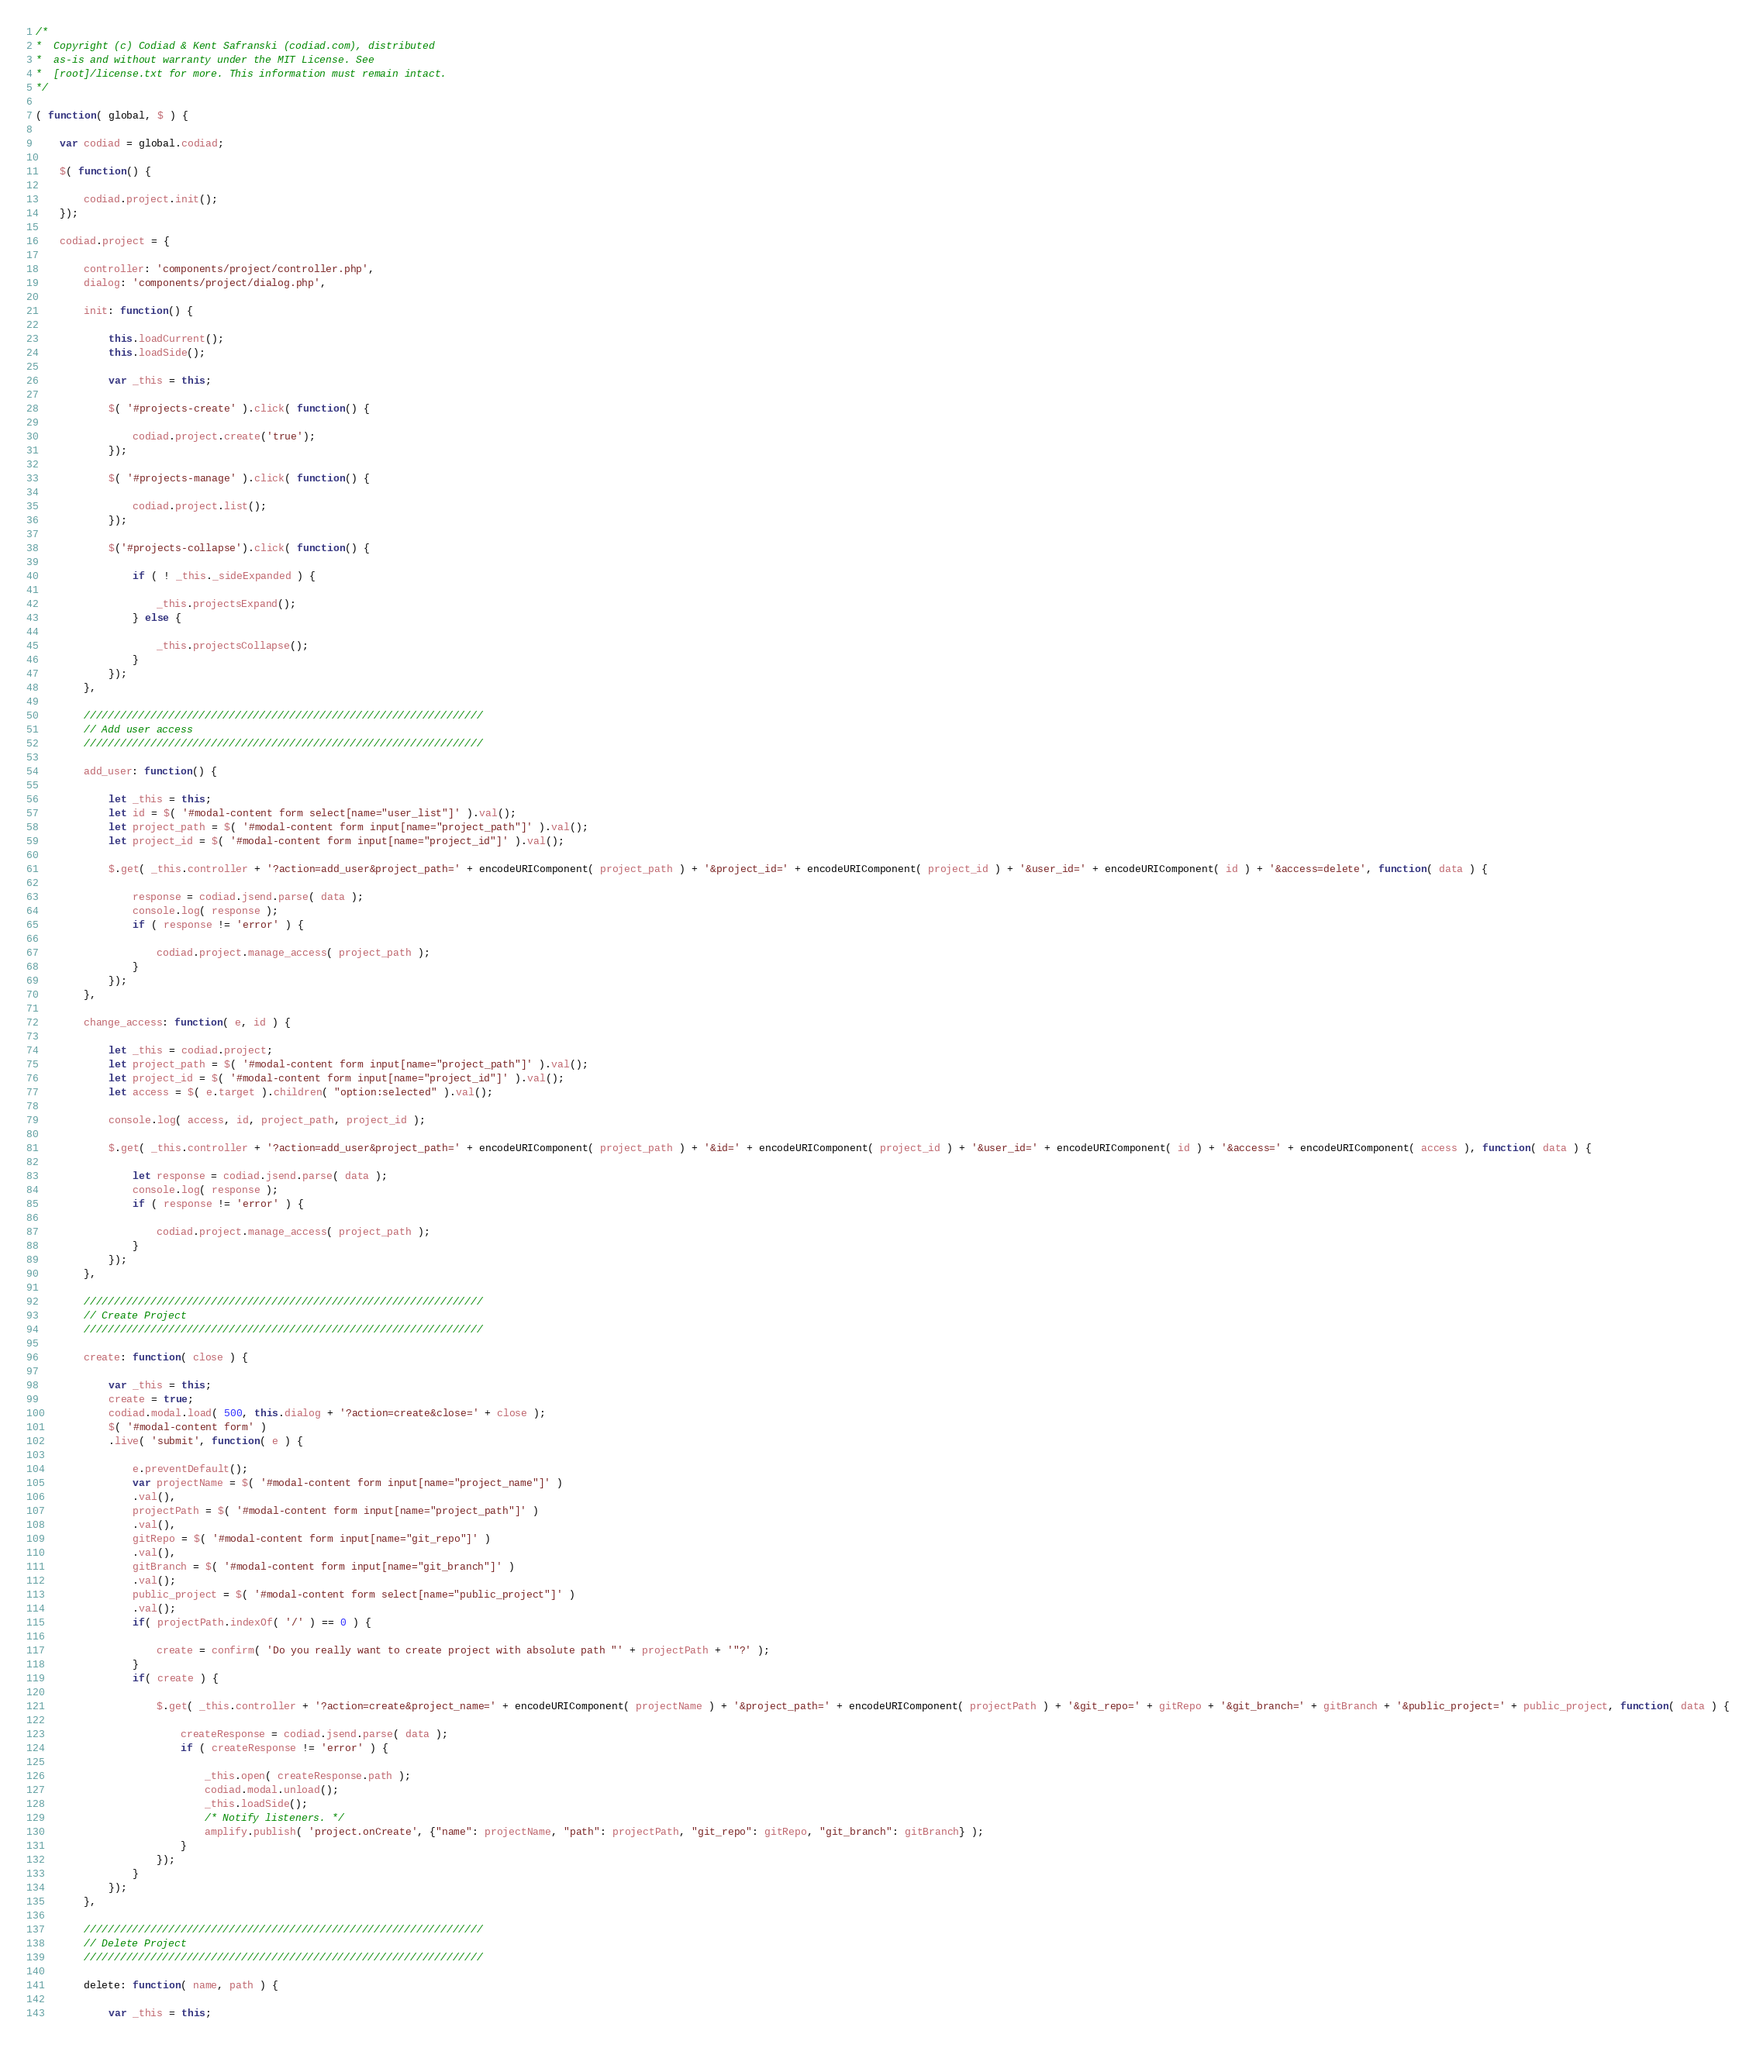<code> <loc_0><loc_0><loc_500><loc_500><_JavaScript_>/*
*  Copyright (c) Codiad & Kent Safranski (codiad.com), distributed
*  as-is and without warranty under the MIT License. See
*  [root]/license.txt for more. This information must remain intact.
*/

( function( global, $ ) {
	
	var codiad = global.codiad;
	
	$( function() {
		
		codiad.project.init();
	});
	
	codiad.project = {
		
		controller: 'components/project/controller.php',
		dialog: 'components/project/dialog.php',
		
		init: function() {
			
			this.loadCurrent();
			this.loadSide();
			
			var _this = this;
			
			$( '#projects-create' ).click( function() {
				
				codiad.project.create('true');
			});
			
			$( '#projects-manage' ).click( function() {
				
				codiad.project.list();
			});
			
			$('#projects-collapse').click( function() {
				
				if ( ! _this._sideExpanded ) {
					
					_this.projectsExpand();
				} else {
					
					_this.projectsCollapse();
				}
			});
		},
		
		//////////////////////////////////////////////////////////////////
		// Add user access
		//////////////////////////////////////////////////////////////////
		
		add_user: function() {
			
			let _this = this;
			let id = $( '#modal-content form select[name="user_list"]' ).val();
			let project_path = $( '#modal-content form input[name="project_path"]' ).val();
			let project_id = $( '#modal-content form input[name="project_id"]' ).val();
			
			$.get( _this.controller + '?action=add_user&project_path=' + encodeURIComponent( project_path ) + '&project_id=' + encodeURIComponent( project_id ) + '&user_id=' + encodeURIComponent( id ) + '&access=delete', function( data ) {
				
				response = codiad.jsend.parse( data );
				console.log( response );
				if ( response != 'error' ) {
					
					codiad.project.manage_access( project_path );
				}
			});
		},
		
		change_access: function( e, id ) {
			
			let _this = codiad.project;
			let project_path = $( '#modal-content form input[name="project_path"]' ).val();
			let project_id = $( '#modal-content form input[name="project_id"]' ).val();
			let access = $( e.target ).children( "option:selected" ).val();
			
			console.log( access, id, project_path, project_id );
			
			$.get( _this.controller + '?action=add_user&project_path=' + encodeURIComponent( project_path ) + '&id=' + encodeURIComponent( project_id ) + '&user_id=' + encodeURIComponent( id ) + '&access=' + encodeURIComponent( access ), function( data ) {
				
				let response = codiad.jsend.parse( data );
				console.log( response );
				if ( response != 'error' ) {
					
					codiad.project.manage_access( project_path );
				}
			});
		},
		
		//////////////////////////////////////////////////////////////////
		// Create Project
		//////////////////////////////////////////////////////////////////
		
		create: function( close ) {
			
			var _this = this;
			create = true;
			codiad.modal.load( 500, this.dialog + '?action=create&close=' + close );
			$( '#modal-content form' )
			.live( 'submit', function( e ) {
				
				e.preventDefault();
				var projectName = $( '#modal-content form input[name="project_name"]' )
				.val(),
				projectPath = $( '#modal-content form input[name="project_path"]' )
				.val(),
				gitRepo = $( '#modal-content form input[name="git_repo"]' )
				.val(),
				gitBranch = $( '#modal-content form input[name="git_branch"]' )
				.val();
				public_project = $( '#modal-content form select[name="public_project"]' )
				.val();
				if( projectPath.indexOf( '/' ) == 0 ) {
					
					create = confirm( 'Do you really want to create project with absolute path "' + projectPath + '"?' );
				}
				if( create ) {
					
					$.get( _this.controller + '?action=create&project_name=' + encodeURIComponent( projectName ) + '&project_path=' + encodeURIComponent( projectPath ) + '&git_repo=' + gitRepo + '&git_branch=' + gitBranch + '&public_project=' + public_project, function( data ) {
						
						createResponse = codiad.jsend.parse( data );
						if ( createResponse != 'error' ) {
							
							_this.open( createResponse.path );
							codiad.modal.unload();
							_this.loadSide();
							/* Notify listeners. */
							amplify.publish( 'project.onCreate', {"name": projectName, "path": projectPath, "git_repo": gitRepo, "git_branch": gitBranch} );
						}
					});
				}
			});
		},
		
		//////////////////////////////////////////////////////////////////
		// Delete Project
		//////////////////////////////////////////////////////////////////
		
		delete: function( name, path ) {
			
			var _this = this;</code> 